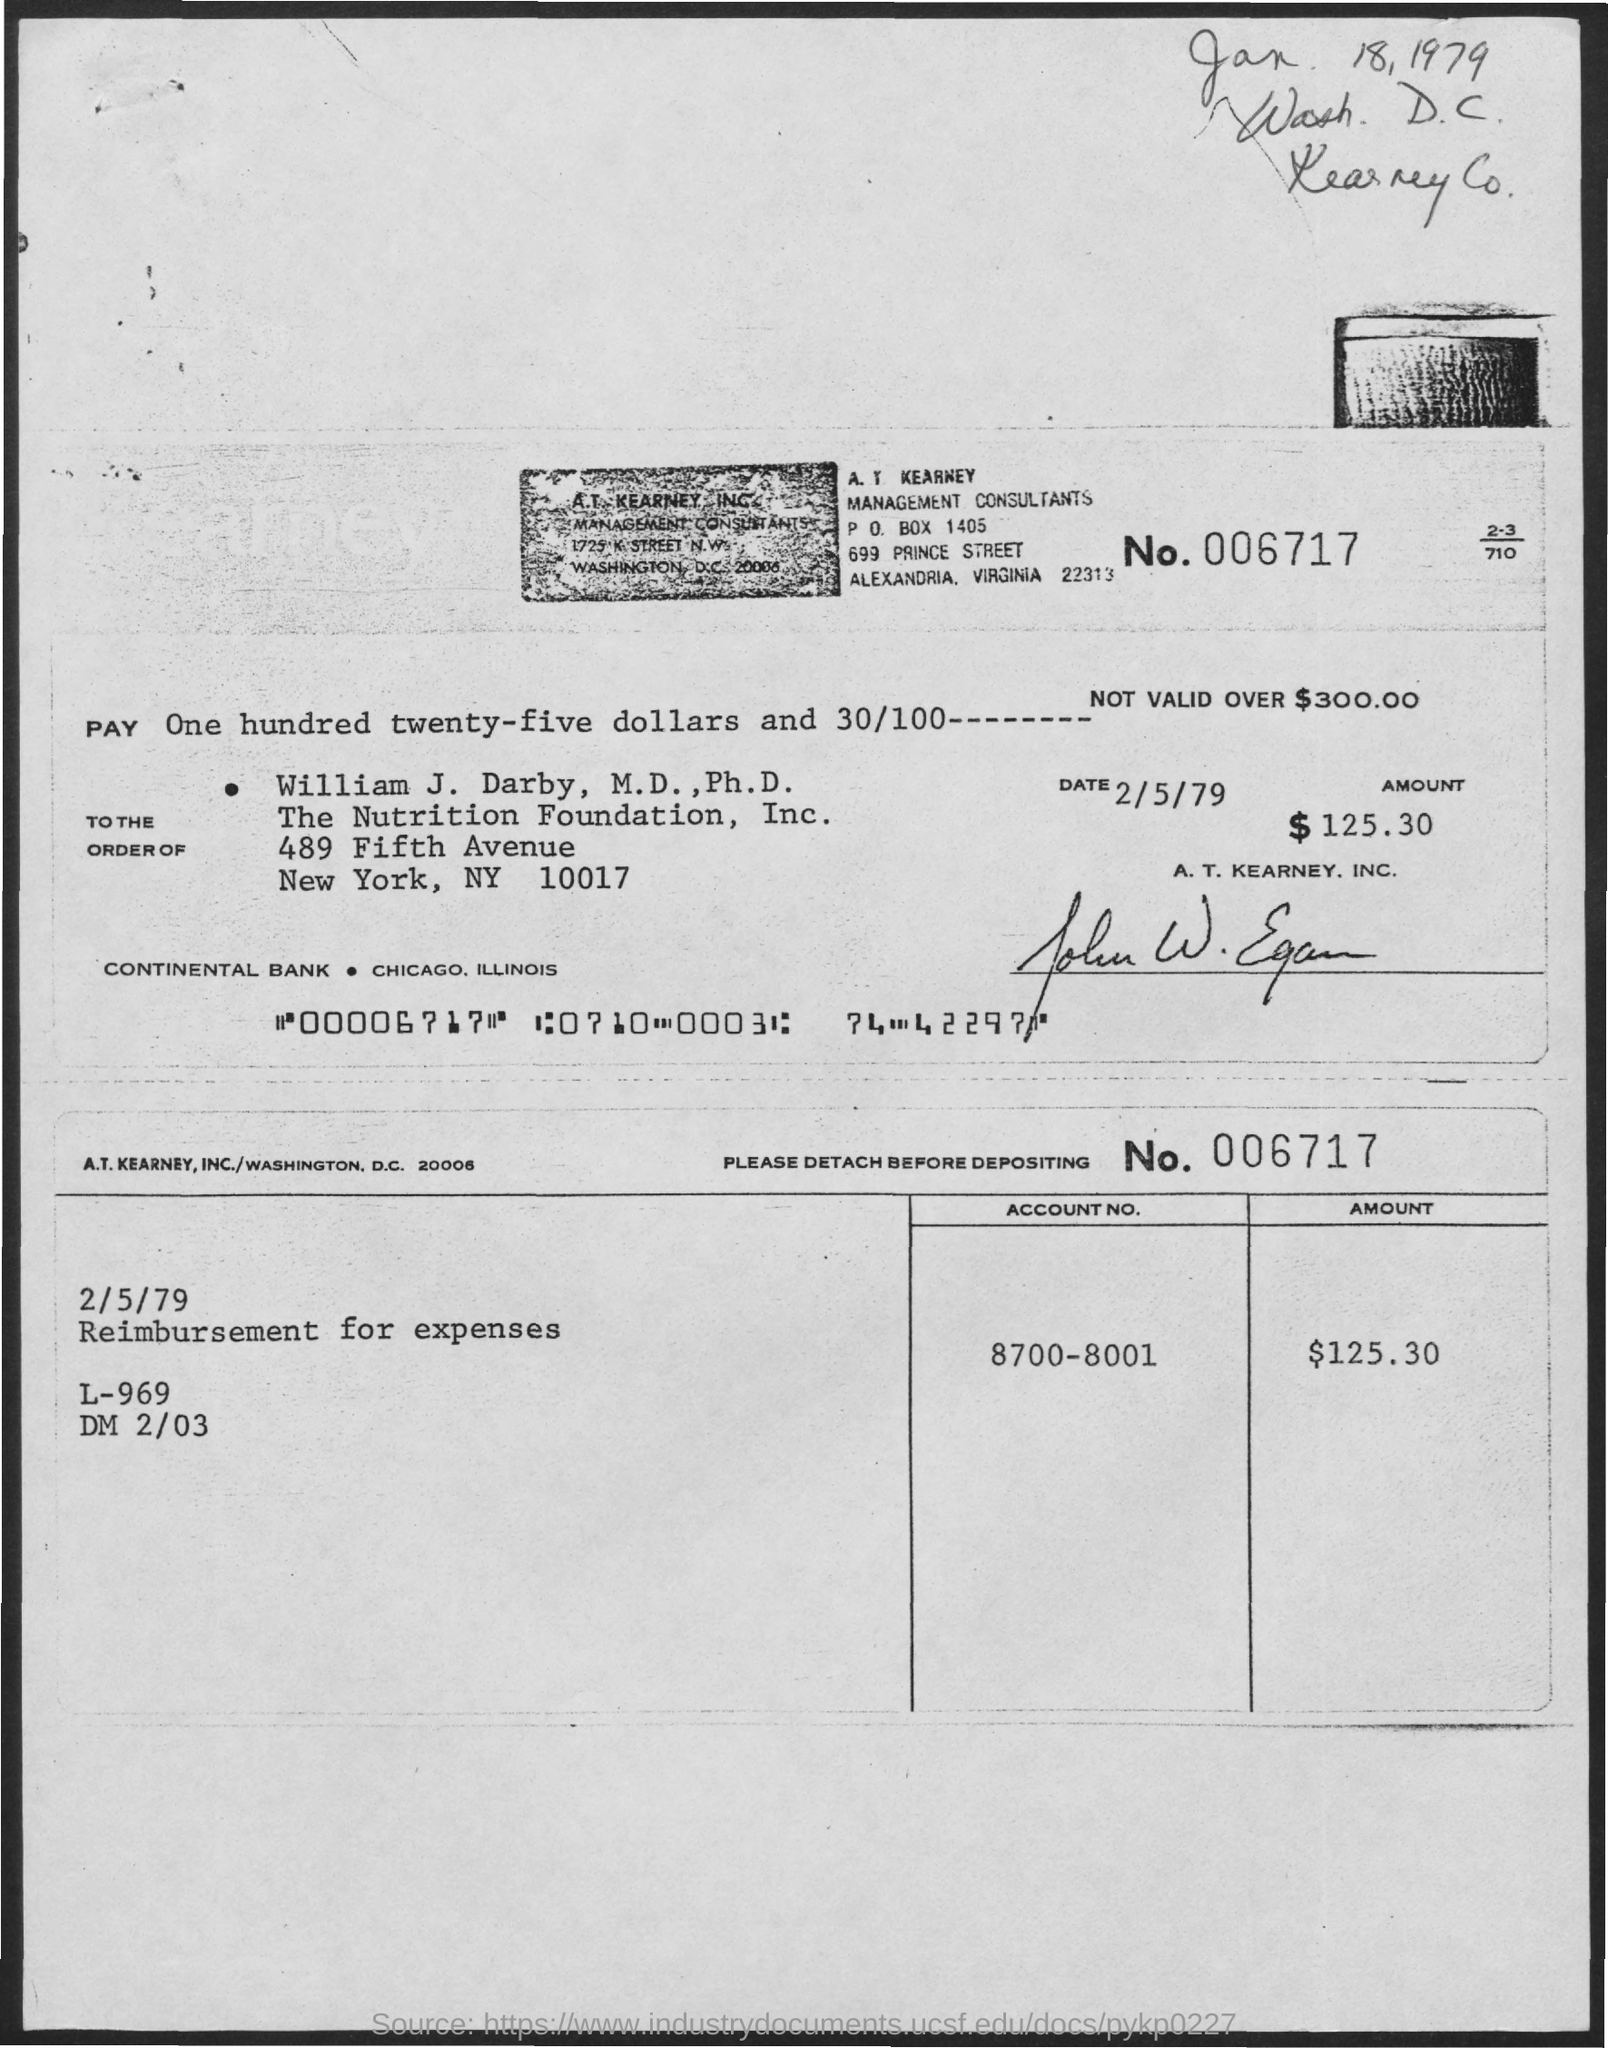What is the Amount?
Your answer should be very brief. $125.30. What is the Account Number?
Offer a very short reply. 8700-8001. What is the Number?
Make the answer very short. 006717. What is the PO Box Number mentioned in the document?
Your answer should be very brief. 1405. 